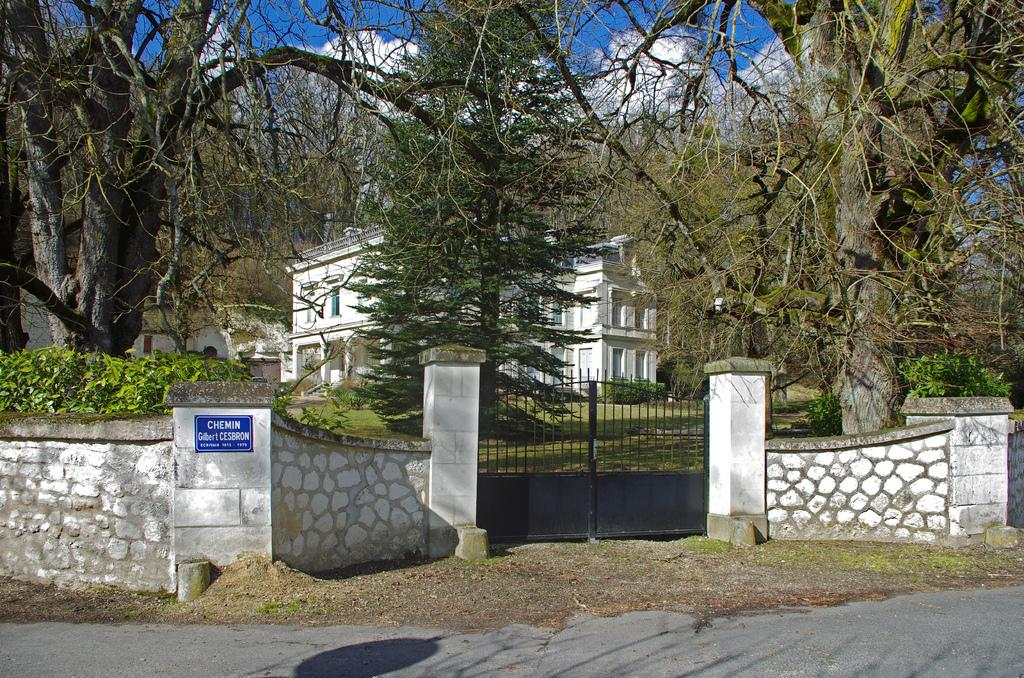What is located in the center of the image? There is a gate and a building in the center of the image. What type of vegetation can be seen on both sides of the image? There are trees on the right side and the left side of the image. What type of flower is being watered by the dog in the image? There is no dog or flower present in the image. What activity is the dog participating in with the flower in the image? There is no dog or flower present in the image, so no such activity can be observed. 